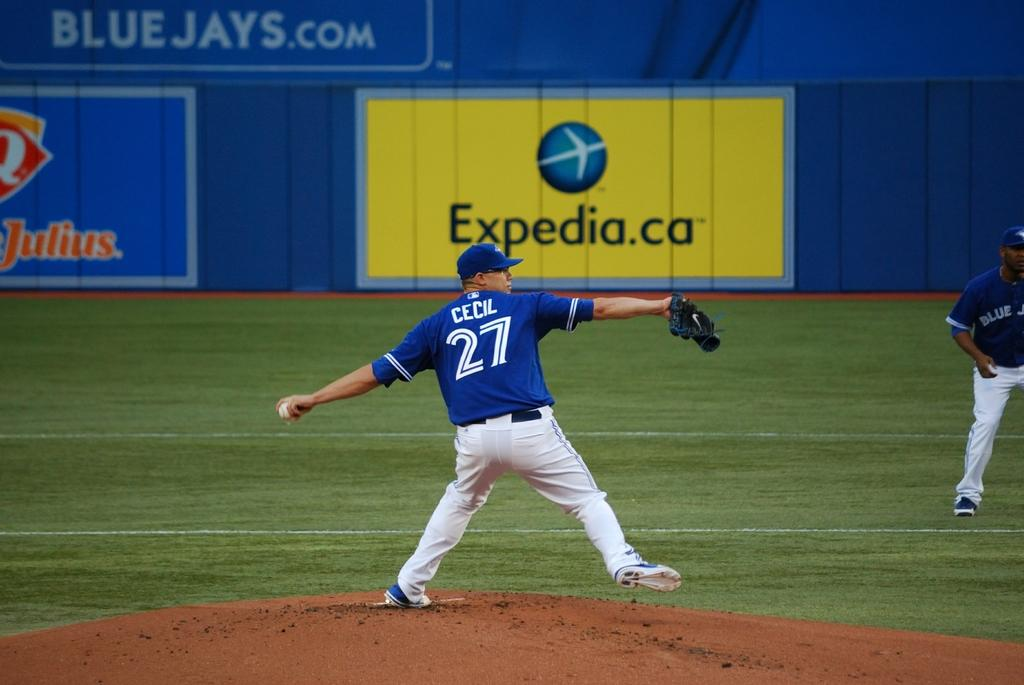<image>
Render a clear and concise summary of the photo. The ads are in the stadium for the Toronto Blue Jays 